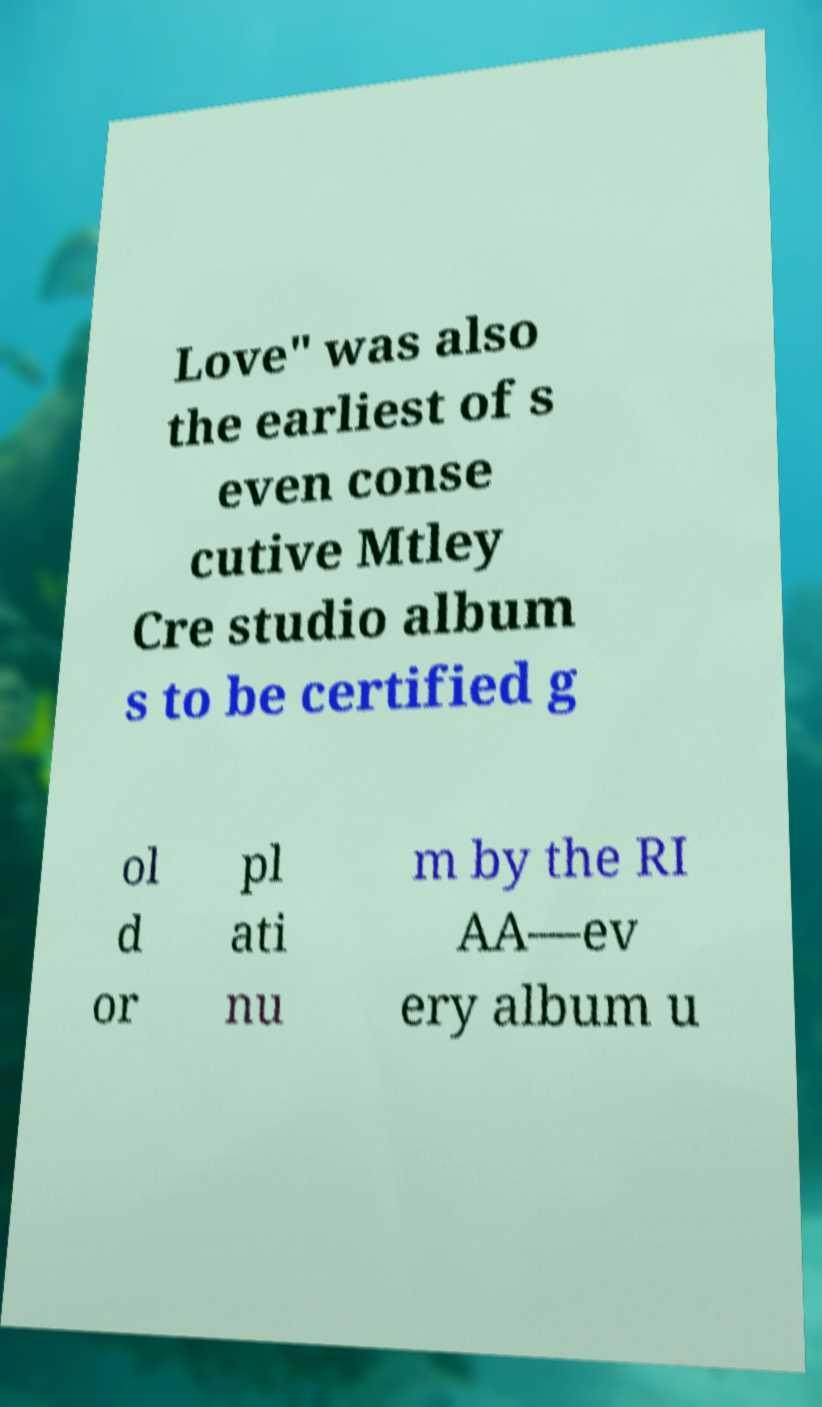What messages or text are displayed in this image? I need them in a readable, typed format. Love" was also the earliest of s even conse cutive Mtley Cre studio album s to be certified g ol d or pl ati nu m by the RI AA―ev ery album u 